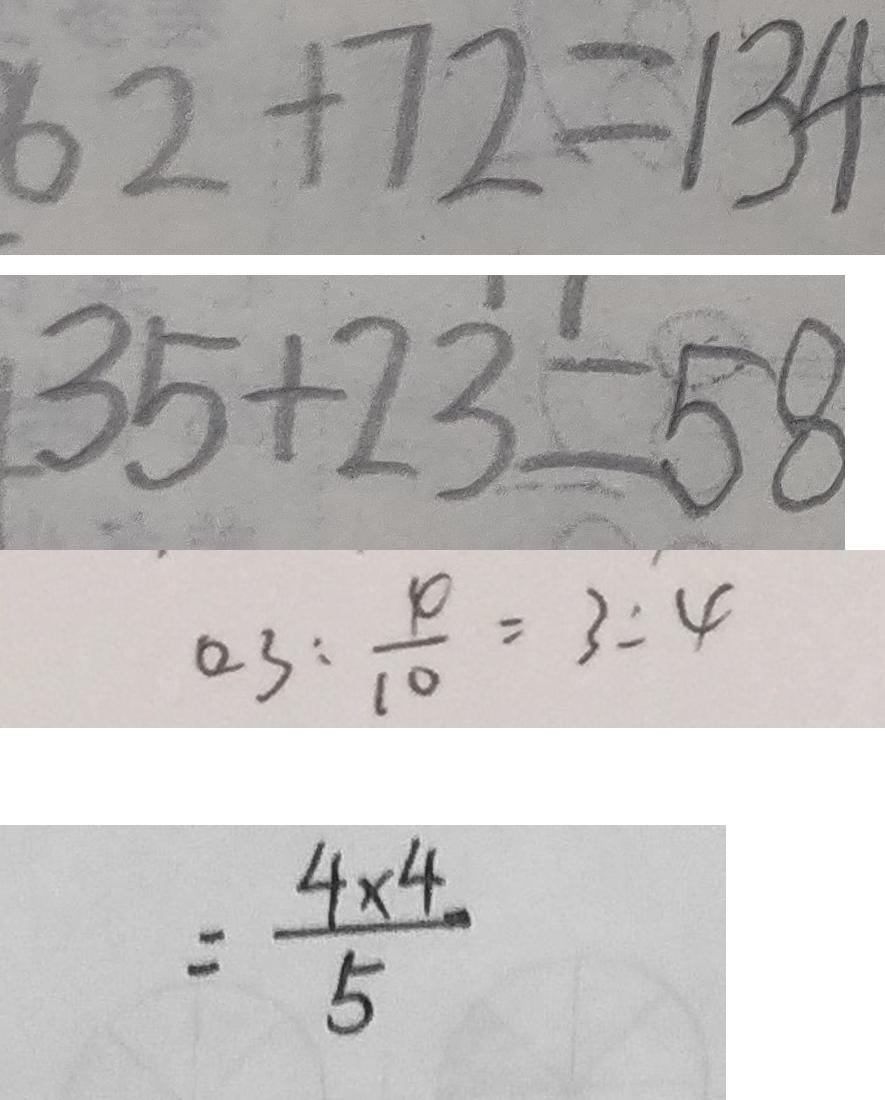Convert formula to latex. <formula><loc_0><loc_0><loc_500><loc_500>6 2 + 7 2 = 1 3 4 
 3 5 + 2 3 = 5 8 
 0 . 3 : \frac { 4 } { 1 0 } = 3 : 4 
 = \frac { 4 \times 4 } { 5 }</formula> 